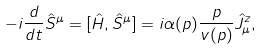Convert formula to latex. <formula><loc_0><loc_0><loc_500><loc_500>- i \frac { d } { d t } \hat { S } ^ { \mu } = [ \hat { H } , \hat { S } ^ { \mu } ] = i \alpha ( p ) \frac { p } { v ( p ) } \hat { J } _ { \mu } ^ { z } ,</formula> 